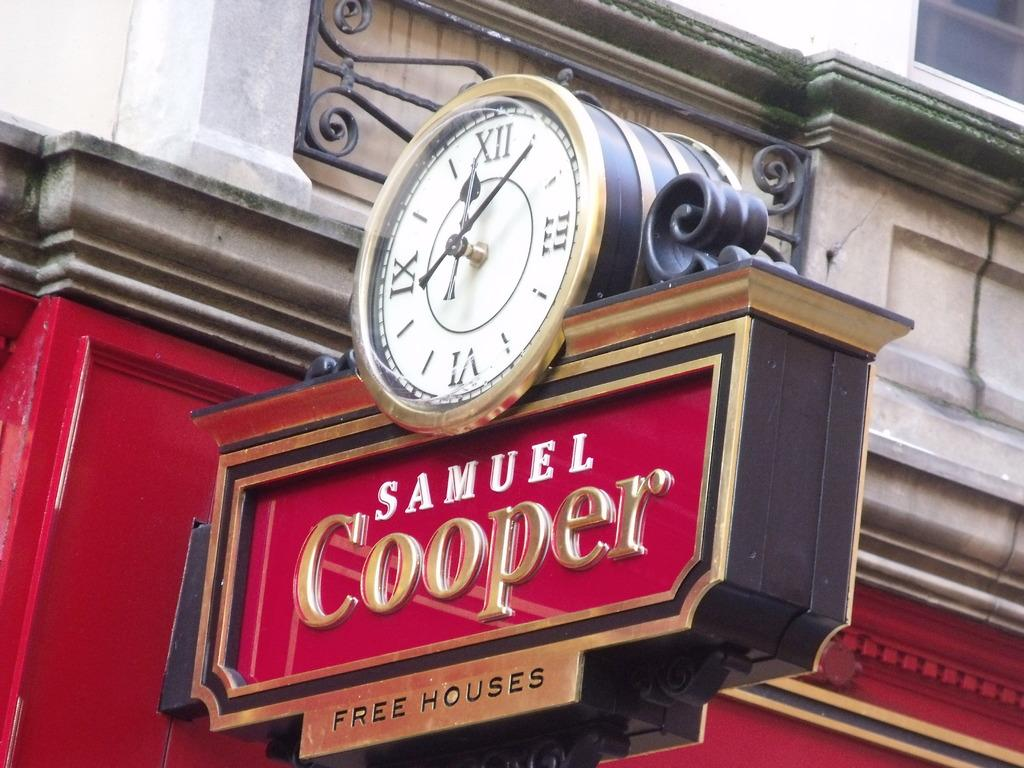<image>
Present a compact description of the photo's key features. A clock is on a store sign that says Samuel Cooper Free Houses. 